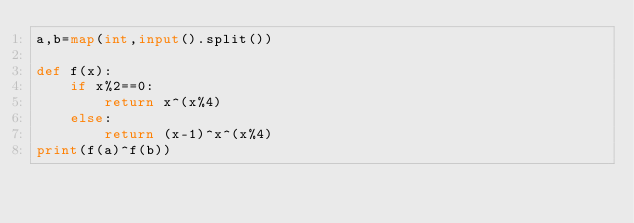<code> <loc_0><loc_0><loc_500><loc_500><_Python_>a,b=map(int,input().split())

def f(x):
    if x%2==0:
        return x^(x%4)
    else:
        return (x-1)^x^(x%4)
print(f(a)^f(b))</code> 